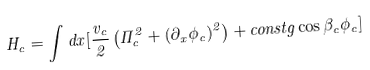Convert formula to latex. <formula><loc_0><loc_0><loc_500><loc_500>H _ { c } = \int d x [ \frac { v _ { c } } { 2 } \left ( \Pi ^ { 2 } _ { c } + ( \partial _ { x } \phi _ { c } ) ^ { 2 } \right ) + c o n s t g \cos \beta _ { c } \phi _ { c } ]</formula> 